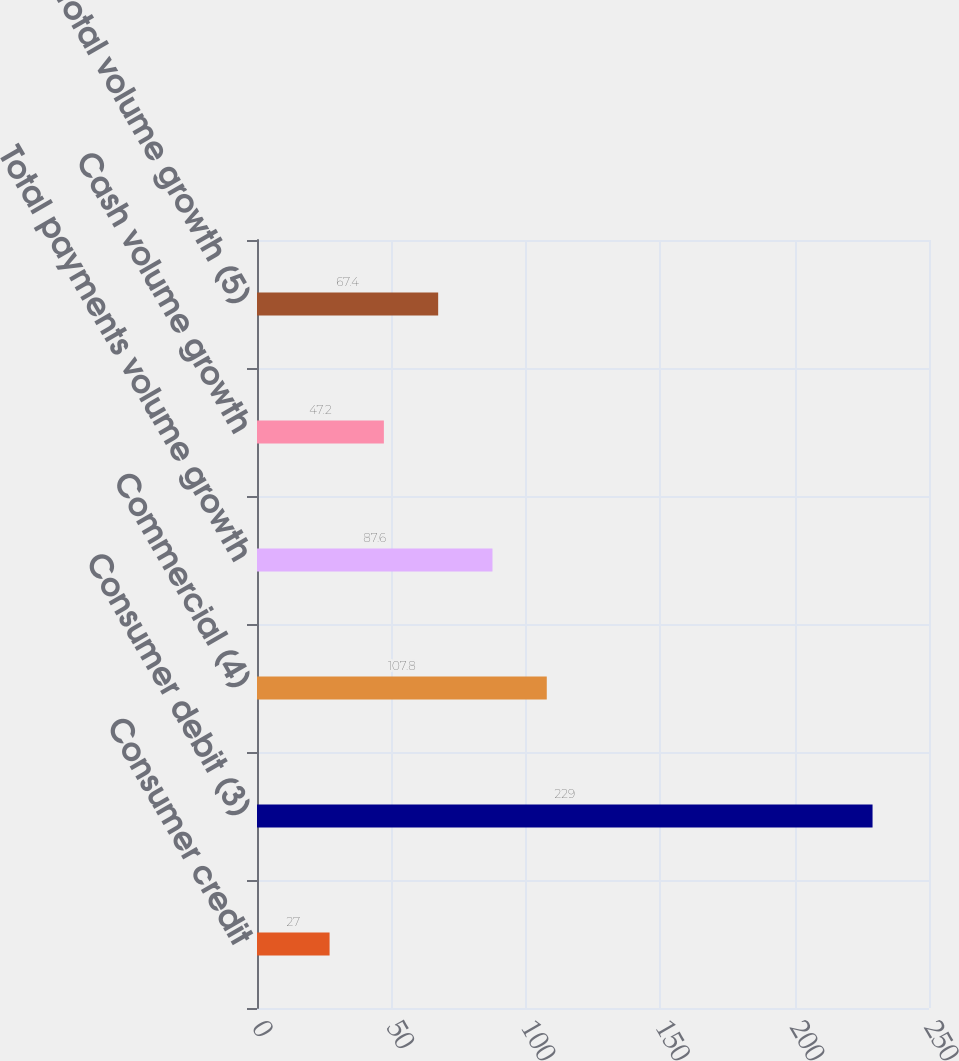Convert chart. <chart><loc_0><loc_0><loc_500><loc_500><bar_chart><fcel>Consumer credit<fcel>Consumer debit (3)<fcel>Commercial (4)<fcel>Total payments volume growth<fcel>Cash volume growth<fcel>Total volume growth (5)<nl><fcel>27<fcel>229<fcel>107.8<fcel>87.6<fcel>47.2<fcel>67.4<nl></chart> 